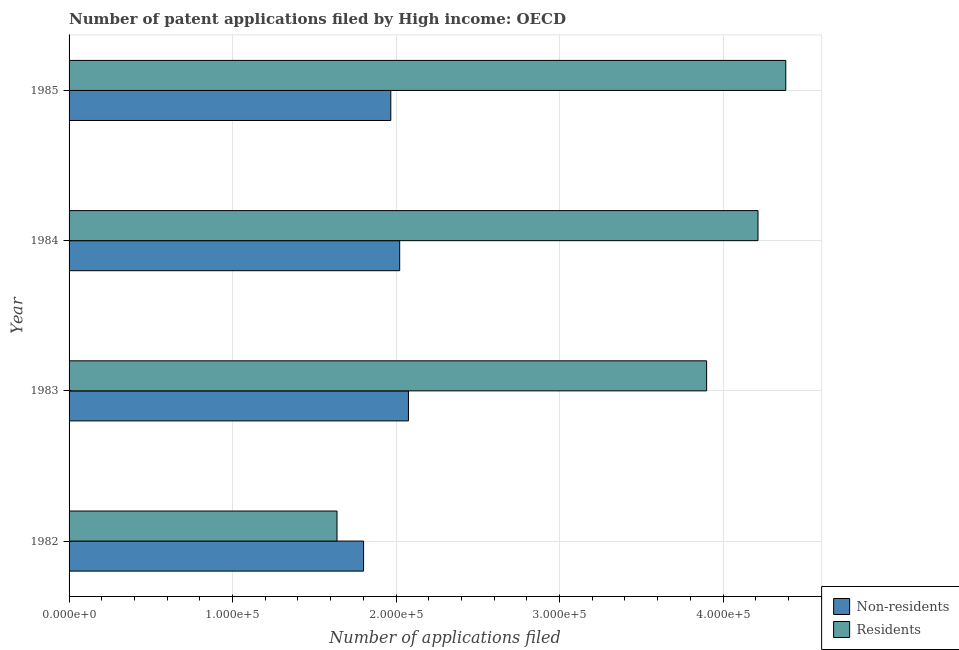How many different coloured bars are there?
Offer a very short reply. 2. How many groups of bars are there?
Ensure brevity in your answer.  4. Are the number of bars per tick equal to the number of legend labels?
Your response must be concise. Yes. Are the number of bars on each tick of the Y-axis equal?
Your answer should be very brief. Yes. How many bars are there on the 3rd tick from the bottom?
Make the answer very short. 2. In how many cases, is the number of bars for a given year not equal to the number of legend labels?
Your answer should be very brief. 0. What is the number of patent applications by residents in 1984?
Offer a terse response. 4.21e+05. Across all years, what is the maximum number of patent applications by residents?
Offer a very short reply. 4.38e+05. Across all years, what is the minimum number of patent applications by non residents?
Offer a terse response. 1.80e+05. What is the total number of patent applications by residents in the graph?
Provide a short and direct response. 1.41e+06. What is the difference between the number of patent applications by non residents in 1982 and that in 1983?
Keep it short and to the point. -2.74e+04. What is the difference between the number of patent applications by non residents in 1985 and the number of patent applications by residents in 1982?
Provide a short and direct response. 3.29e+04. What is the average number of patent applications by residents per year?
Keep it short and to the point. 3.53e+05. In the year 1984, what is the difference between the number of patent applications by non residents and number of patent applications by residents?
Give a very brief answer. -2.19e+05. What is the ratio of the number of patent applications by non residents in 1983 to that in 1985?
Make the answer very short. 1.05. Is the number of patent applications by non residents in 1982 less than that in 1983?
Your answer should be very brief. Yes. Is the difference between the number of patent applications by residents in 1983 and 1985 greater than the difference between the number of patent applications by non residents in 1983 and 1985?
Make the answer very short. No. What is the difference between the highest and the second highest number of patent applications by non residents?
Offer a very short reply. 5365. What is the difference between the highest and the lowest number of patent applications by residents?
Provide a succinct answer. 2.74e+05. What does the 2nd bar from the top in 1982 represents?
Your response must be concise. Non-residents. What does the 1st bar from the bottom in 1984 represents?
Your answer should be very brief. Non-residents. How many bars are there?
Provide a short and direct response. 8. Are all the bars in the graph horizontal?
Your response must be concise. Yes. Are the values on the major ticks of X-axis written in scientific E-notation?
Your response must be concise. Yes. Does the graph contain any zero values?
Make the answer very short. No. Does the graph contain grids?
Make the answer very short. Yes. Where does the legend appear in the graph?
Offer a very short reply. Bottom right. What is the title of the graph?
Your response must be concise. Number of patent applications filed by High income: OECD. What is the label or title of the X-axis?
Make the answer very short. Number of applications filed. What is the Number of applications filed in Non-residents in 1982?
Provide a short and direct response. 1.80e+05. What is the Number of applications filed of Residents in 1982?
Provide a short and direct response. 1.64e+05. What is the Number of applications filed of Non-residents in 1983?
Ensure brevity in your answer.  2.08e+05. What is the Number of applications filed in Residents in 1983?
Provide a succinct answer. 3.90e+05. What is the Number of applications filed in Non-residents in 1984?
Provide a short and direct response. 2.02e+05. What is the Number of applications filed in Residents in 1984?
Provide a short and direct response. 4.21e+05. What is the Number of applications filed in Non-residents in 1985?
Keep it short and to the point. 1.97e+05. What is the Number of applications filed of Residents in 1985?
Offer a terse response. 4.38e+05. Across all years, what is the maximum Number of applications filed in Non-residents?
Your response must be concise. 2.08e+05. Across all years, what is the maximum Number of applications filed of Residents?
Your answer should be compact. 4.38e+05. Across all years, what is the minimum Number of applications filed in Non-residents?
Offer a very short reply. 1.80e+05. Across all years, what is the minimum Number of applications filed in Residents?
Your answer should be compact. 1.64e+05. What is the total Number of applications filed in Non-residents in the graph?
Provide a succinct answer. 7.87e+05. What is the total Number of applications filed in Residents in the graph?
Provide a short and direct response. 1.41e+06. What is the difference between the Number of applications filed in Non-residents in 1982 and that in 1983?
Offer a very short reply. -2.74e+04. What is the difference between the Number of applications filed in Residents in 1982 and that in 1983?
Keep it short and to the point. -2.26e+05. What is the difference between the Number of applications filed in Non-residents in 1982 and that in 1984?
Provide a short and direct response. -2.21e+04. What is the difference between the Number of applications filed of Residents in 1982 and that in 1984?
Offer a very short reply. -2.57e+05. What is the difference between the Number of applications filed in Non-residents in 1982 and that in 1985?
Make the answer very short. -1.66e+04. What is the difference between the Number of applications filed of Residents in 1982 and that in 1985?
Provide a succinct answer. -2.74e+05. What is the difference between the Number of applications filed of Non-residents in 1983 and that in 1984?
Give a very brief answer. 5365. What is the difference between the Number of applications filed of Residents in 1983 and that in 1984?
Provide a short and direct response. -3.14e+04. What is the difference between the Number of applications filed in Non-residents in 1983 and that in 1985?
Your answer should be compact. 1.08e+04. What is the difference between the Number of applications filed of Residents in 1983 and that in 1985?
Provide a short and direct response. -4.84e+04. What is the difference between the Number of applications filed of Non-residents in 1984 and that in 1985?
Your response must be concise. 5435. What is the difference between the Number of applications filed of Residents in 1984 and that in 1985?
Ensure brevity in your answer.  -1.70e+04. What is the difference between the Number of applications filed in Non-residents in 1982 and the Number of applications filed in Residents in 1983?
Make the answer very short. -2.10e+05. What is the difference between the Number of applications filed in Non-residents in 1982 and the Number of applications filed in Residents in 1984?
Keep it short and to the point. -2.41e+05. What is the difference between the Number of applications filed of Non-residents in 1982 and the Number of applications filed of Residents in 1985?
Ensure brevity in your answer.  -2.58e+05. What is the difference between the Number of applications filed in Non-residents in 1983 and the Number of applications filed in Residents in 1984?
Keep it short and to the point. -2.14e+05. What is the difference between the Number of applications filed in Non-residents in 1983 and the Number of applications filed in Residents in 1985?
Make the answer very short. -2.31e+05. What is the difference between the Number of applications filed of Non-residents in 1984 and the Number of applications filed of Residents in 1985?
Your answer should be very brief. -2.36e+05. What is the average Number of applications filed in Non-residents per year?
Your answer should be very brief. 1.97e+05. What is the average Number of applications filed of Residents per year?
Keep it short and to the point. 3.53e+05. In the year 1982, what is the difference between the Number of applications filed of Non-residents and Number of applications filed of Residents?
Ensure brevity in your answer.  1.62e+04. In the year 1983, what is the difference between the Number of applications filed of Non-residents and Number of applications filed of Residents?
Your answer should be compact. -1.82e+05. In the year 1984, what is the difference between the Number of applications filed in Non-residents and Number of applications filed in Residents?
Make the answer very short. -2.19e+05. In the year 1985, what is the difference between the Number of applications filed in Non-residents and Number of applications filed in Residents?
Your response must be concise. -2.42e+05. What is the ratio of the Number of applications filed in Non-residents in 1982 to that in 1983?
Ensure brevity in your answer.  0.87. What is the ratio of the Number of applications filed in Residents in 1982 to that in 1983?
Ensure brevity in your answer.  0.42. What is the ratio of the Number of applications filed of Non-residents in 1982 to that in 1984?
Provide a short and direct response. 0.89. What is the ratio of the Number of applications filed in Residents in 1982 to that in 1984?
Ensure brevity in your answer.  0.39. What is the ratio of the Number of applications filed of Non-residents in 1982 to that in 1985?
Make the answer very short. 0.92. What is the ratio of the Number of applications filed in Residents in 1982 to that in 1985?
Offer a very short reply. 0.37. What is the ratio of the Number of applications filed in Non-residents in 1983 to that in 1984?
Provide a short and direct response. 1.03. What is the ratio of the Number of applications filed in Residents in 1983 to that in 1984?
Keep it short and to the point. 0.93. What is the ratio of the Number of applications filed in Non-residents in 1983 to that in 1985?
Offer a terse response. 1.05. What is the ratio of the Number of applications filed in Residents in 1983 to that in 1985?
Provide a short and direct response. 0.89. What is the ratio of the Number of applications filed of Non-residents in 1984 to that in 1985?
Provide a succinct answer. 1.03. What is the ratio of the Number of applications filed in Residents in 1984 to that in 1985?
Give a very brief answer. 0.96. What is the difference between the highest and the second highest Number of applications filed in Non-residents?
Provide a succinct answer. 5365. What is the difference between the highest and the second highest Number of applications filed in Residents?
Give a very brief answer. 1.70e+04. What is the difference between the highest and the lowest Number of applications filed of Non-residents?
Offer a terse response. 2.74e+04. What is the difference between the highest and the lowest Number of applications filed of Residents?
Make the answer very short. 2.74e+05. 